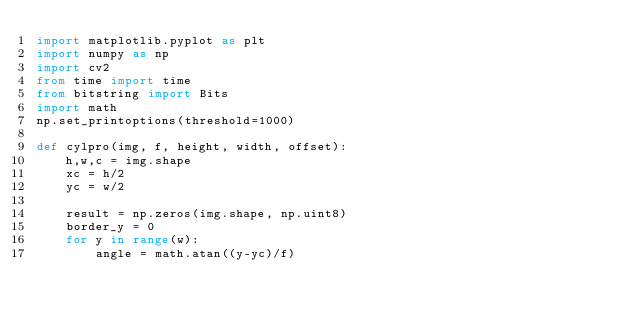Convert code to text. <code><loc_0><loc_0><loc_500><loc_500><_Python_>import matplotlib.pyplot as plt
import numpy as np
import cv2
from time import time
from bitstring import Bits
import math
np.set_printoptions(threshold=1000)

def cylpro(img, f, height, width, offset):
    h,w,c = img.shape
    xc = h/2
    yc = w/2

    result = np.zeros(img.shape, np.uint8)
    border_y = 0
    for y in range(w):
        angle = math.atan((y-yc)/f)
        </code> 